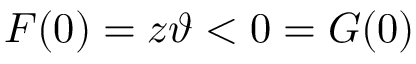<formula> <loc_0><loc_0><loc_500><loc_500>F ( 0 ) = z \vartheta < 0 = G ( 0 )</formula> 